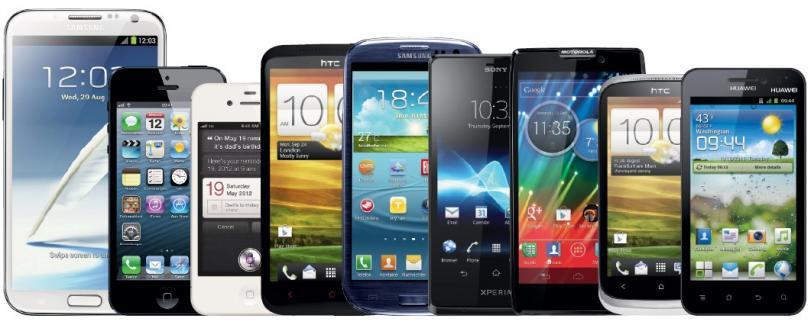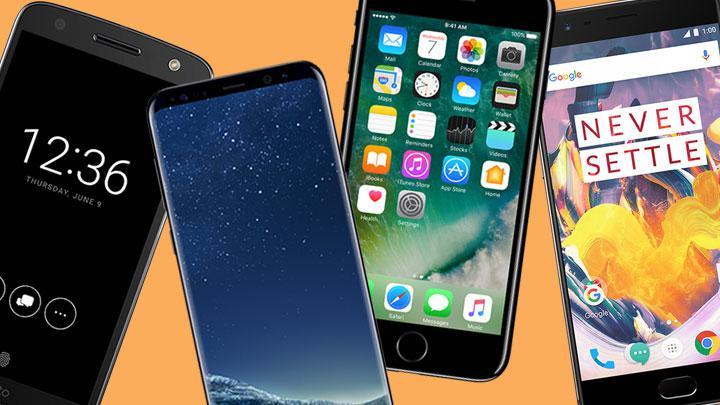The first image is the image on the left, the second image is the image on the right. Examine the images to the left and right. Is the description "No image contains more than 9 screened devices, and one image shows multiple devices in a straight row." accurate? Answer yes or no. Yes. The first image is the image on the left, the second image is the image on the right. Assess this claim about the two images: "The right image contains no more than four smart phones.". Correct or not? Answer yes or no. Yes. 